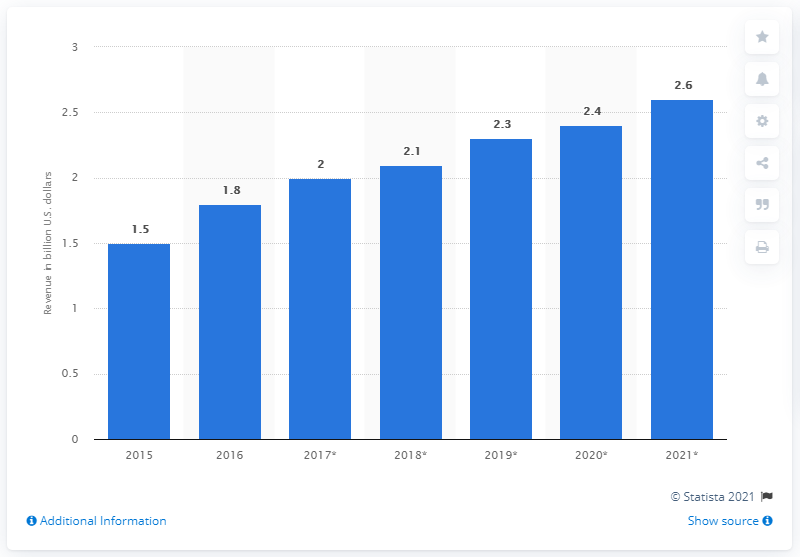Highlight a few significant elements in this photo. According to a report, global sales of magnetic sensors in 2016 were 1.8... 